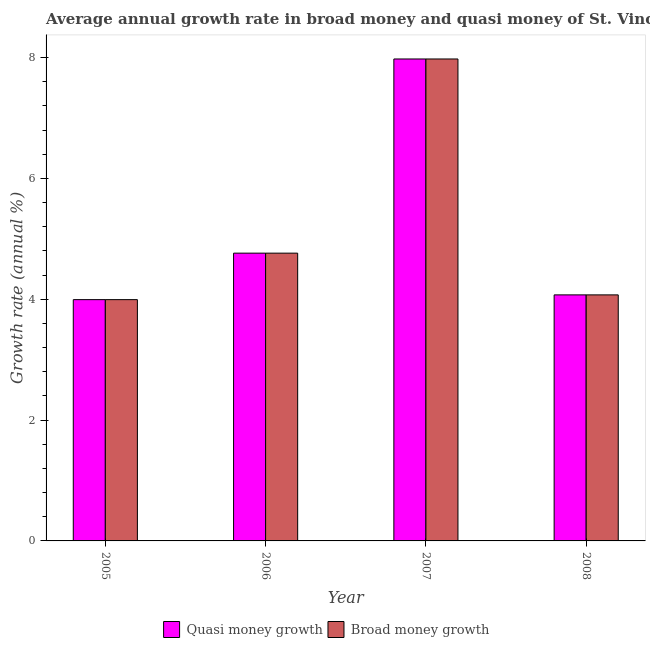How many different coloured bars are there?
Your answer should be compact. 2. How many groups of bars are there?
Offer a terse response. 4. Are the number of bars per tick equal to the number of legend labels?
Ensure brevity in your answer.  Yes. How many bars are there on the 2nd tick from the left?
Your answer should be very brief. 2. How many bars are there on the 4th tick from the right?
Keep it short and to the point. 2. What is the label of the 4th group of bars from the left?
Make the answer very short. 2008. In how many cases, is the number of bars for a given year not equal to the number of legend labels?
Provide a short and direct response. 0. What is the annual growth rate in quasi money in 2007?
Offer a terse response. 7.98. Across all years, what is the maximum annual growth rate in broad money?
Keep it short and to the point. 7.98. Across all years, what is the minimum annual growth rate in broad money?
Keep it short and to the point. 3.99. What is the total annual growth rate in broad money in the graph?
Provide a short and direct response. 20.8. What is the difference between the annual growth rate in broad money in 2005 and that in 2006?
Offer a terse response. -0.77. What is the difference between the annual growth rate in quasi money in 2005 and the annual growth rate in broad money in 2006?
Provide a succinct answer. -0.77. What is the average annual growth rate in quasi money per year?
Your answer should be very brief. 5.2. In how many years, is the annual growth rate in quasi money greater than 2.4 %?
Ensure brevity in your answer.  4. What is the ratio of the annual growth rate in broad money in 2006 to that in 2008?
Give a very brief answer. 1.17. Is the annual growth rate in quasi money in 2006 less than that in 2007?
Your answer should be compact. Yes. Is the difference between the annual growth rate in broad money in 2006 and 2007 greater than the difference between the annual growth rate in quasi money in 2006 and 2007?
Offer a terse response. No. What is the difference between the highest and the second highest annual growth rate in broad money?
Your answer should be very brief. 3.21. What is the difference between the highest and the lowest annual growth rate in broad money?
Offer a very short reply. 3.98. Is the sum of the annual growth rate in broad money in 2005 and 2008 greater than the maximum annual growth rate in quasi money across all years?
Give a very brief answer. Yes. What does the 2nd bar from the left in 2007 represents?
Offer a terse response. Broad money growth. What does the 1st bar from the right in 2008 represents?
Offer a very short reply. Broad money growth. Are all the bars in the graph horizontal?
Your response must be concise. No. How many years are there in the graph?
Provide a short and direct response. 4. Does the graph contain any zero values?
Make the answer very short. No. Does the graph contain grids?
Provide a succinct answer. No. How many legend labels are there?
Your answer should be very brief. 2. How are the legend labels stacked?
Provide a short and direct response. Horizontal. What is the title of the graph?
Provide a short and direct response. Average annual growth rate in broad money and quasi money of St. Vincent and the Grenadines. What is the label or title of the X-axis?
Offer a terse response. Year. What is the label or title of the Y-axis?
Keep it short and to the point. Growth rate (annual %). What is the Growth rate (annual %) in Quasi money growth in 2005?
Give a very brief answer. 3.99. What is the Growth rate (annual %) of Broad money growth in 2005?
Your answer should be compact. 3.99. What is the Growth rate (annual %) of Quasi money growth in 2006?
Your answer should be compact. 4.76. What is the Growth rate (annual %) in Broad money growth in 2006?
Keep it short and to the point. 4.76. What is the Growth rate (annual %) in Quasi money growth in 2007?
Your response must be concise. 7.98. What is the Growth rate (annual %) of Broad money growth in 2007?
Provide a short and direct response. 7.98. What is the Growth rate (annual %) of Quasi money growth in 2008?
Ensure brevity in your answer.  4.07. What is the Growth rate (annual %) in Broad money growth in 2008?
Your response must be concise. 4.07. Across all years, what is the maximum Growth rate (annual %) of Quasi money growth?
Ensure brevity in your answer.  7.98. Across all years, what is the maximum Growth rate (annual %) of Broad money growth?
Your answer should be very brief. 7.98. Across all years, what is the minimum Growth rate (annual %) in Quasi money growth?
Your answer should be very brief. 3.99. Across all years, what is the minimum Growth rate (annual %) of Broad money growth?
Offer a terse response. 3.99. What is the total Growth rate (annual %) in Quasi money growth in the graph?
Your response must be concise. 20.8. What is the total Growth rate (annual %) in Broad money growth in the graph?
Ensure brevity in your answer.  20.8. What is the difference between the Growth rate (annual %) in Quasi money growth in 2005 and that in 2006?
Make the answer very short. -0.77. What is the difference between the Growth rate (annual %) in Broad money growth in 2005 and that in 2006?
Keep it short and to the point. -0.77. What is the difference between the Growth rate (annual %) in Quasi money growth in 2005 and that in 2007?
Offer a very short reply. -3.98. What is the difference between the Growth rate (annual %) of Broad money growth in 2005 and that in 2007?
Offer a very short reply. -3.98. What is the difference between the Growth rate (annual %) in Quasi money growth in 2005 and that in 2008?
Provide a short and direct response. -0.08. What is the difference between the Growth rate (annual %) of Broad money growth in 2005 and that in 2008?
Make the answer very short. -0.08. What is the difference between the Growth rate (annual %) in Quasi money growth in 2006 and that in 2007?
Offer a very short reply. -3.21. What is the difference between the Growth rate (annual %) in Broad money growth in 2006 and that in 2007?
Your answer should be compact. -3.21. What is the difference between the Growth rate (annual %) of Quasi money growth in 2006 and that in 2008?
Make the answer very short. 0.69. What is the difference between the Growth rate (annual %) of Broad money growth in 2006 and that in 2008?
Offer a very short reply. 0.69. What is the difference between the Growth rate (annual %) in Quasi money growth in 2007 and that in 2008?
Provide a succinct answer. 3.9. What is the difference between the Growth rate (annual %) of Broad money growth in 2007 and that in 2008?
Your answer should be very brief. 3.9. What is the difference between the Growth rate (annual %) of Quasi money growth in 2005 and the Growth rate (annual %) of Broad money growth in 2006?
Your response must be concise. -0.77. What is the difference between the Growth rate (annual %) of Quasi money growth in 2005 and the Growth rate (annual %) of Broad money growth in 2007?
Offer a very short reply. -3.98. What is the difference between the Growth rate (annual %) of Quasi money growth in 2005 and the Growth rate (annual %) of Broad money growth in 2008?
Offer a terse response. -0.08. What is the difference between the Growth rate (annual %) of Quasi money growth in 2006 and the Growth rate (annual %) of Broad money growth in 2007?
Offer a very short reply. -3.21. What is the difference between the Growth rate (annual %) of Quasi money growth in 2006 and the Growth rate (annual %) of Broad money growth in 2008?
Offer a very short reply. 0.69. What is the difference between the Growth rate (annual %) in Quasi money growth in 2007 and the Growth rate (annual %) in Broad money growth in 2008?
Your answer should be very brief. 3.9. What is the average Growth rate (annual %) in Quasi money growth per year?
Offer a very short reply. 5.2. What is the average Growth rate (annual %) in Broad money growth per year?
Your response must be concise. 5.2. What is the ratio of the Growth rate (annual %) in Quasi money growth in 2005 to that in 2006?
Provide a succinct answer. 0.84. What is the ratio of the Growth rate (annual %) in Broad money growth in 2005 to that in 2006?
Your answer should be very brief. 0.84. What is the ratio of the Growth rate (annual %) of Quasi money growth in 2005 to that in 2007?
Your answer should be compact. 0.5. What is the ratio of the Growth rate (annual %) in Broad money growth in 2005 to that in 2007?
Provide a succinct answer. 0.5. What is the ratio of the Growth rate (annual %) of Quasi money growth in 2005 to that in 2008?
Make the answer very short. 0.98. What is the ratio of the Growth rate (annual %) in Broad money growth in 2005 to that in 2008?
Offer a very short reply. 0.98. What is the ratio of the Growth rate (annual %) in Quasi money growth in 2006 to that in 2007?
Give a very brief answer. 0.6. What is the ratio of the Growth rate (annual %) of Broad money growth in 2006 to that in 2007?
Keep it short and to the point. 0.6. What is the ratio of the Growth rate (annual %) in Quasi money growth in 2006 to that in 2008?
Provide a succinct answer. 1.17. What is the ratio of the Growth rate (annual %) in Broad money growth in 2006 to that in 2008?
Make the answer very short. 1.17. What is the ratio of the Growth rate (annual %) in Quasi money growth in 2007 to that in 2008?
Offer a terse response. 1.96. What is the ratio of the Growth rate (annual %) in Broad money growth in 2007 to that in 2008?
Your answer should be very brief. 1.96. What is the difference between the highest and the second highest Growth rate (annual %) of Quasi money growth?
Keep it short and to the point. 3.21. What is the difference between the highest and the second highest Growth rate (annual %) in Broad money growth?
Offer a very short reply. 3.21. What is the difference between the highest and the lowest Growth rate (annual %) of Quasi money growth?
Make the answer very short. 3.98. What is the difference between the highest and the lowest Growth rate (annual %) in Broad money growth?
Offer a very short reply. 3.98. 